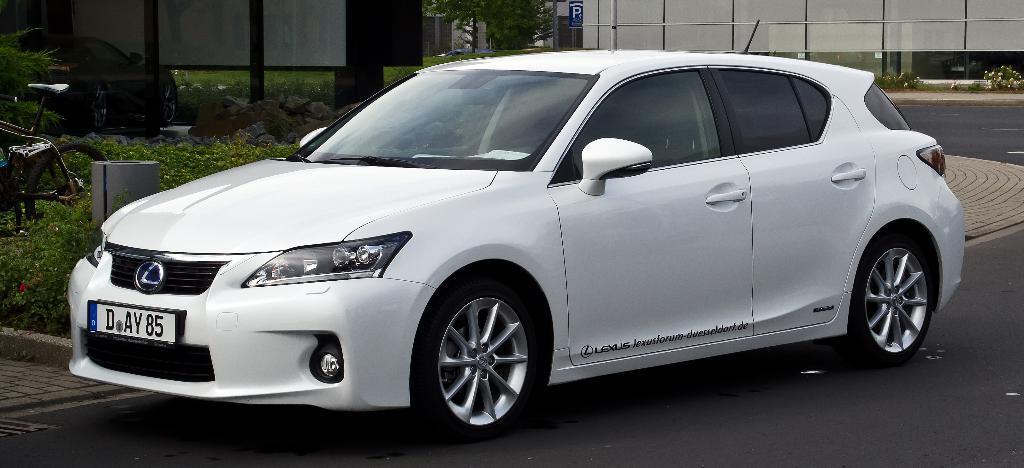How would you summarize this image in a sentence or two? In this picture we can see a white car on the road, bicycle, plants, stones, signboard, wall. 